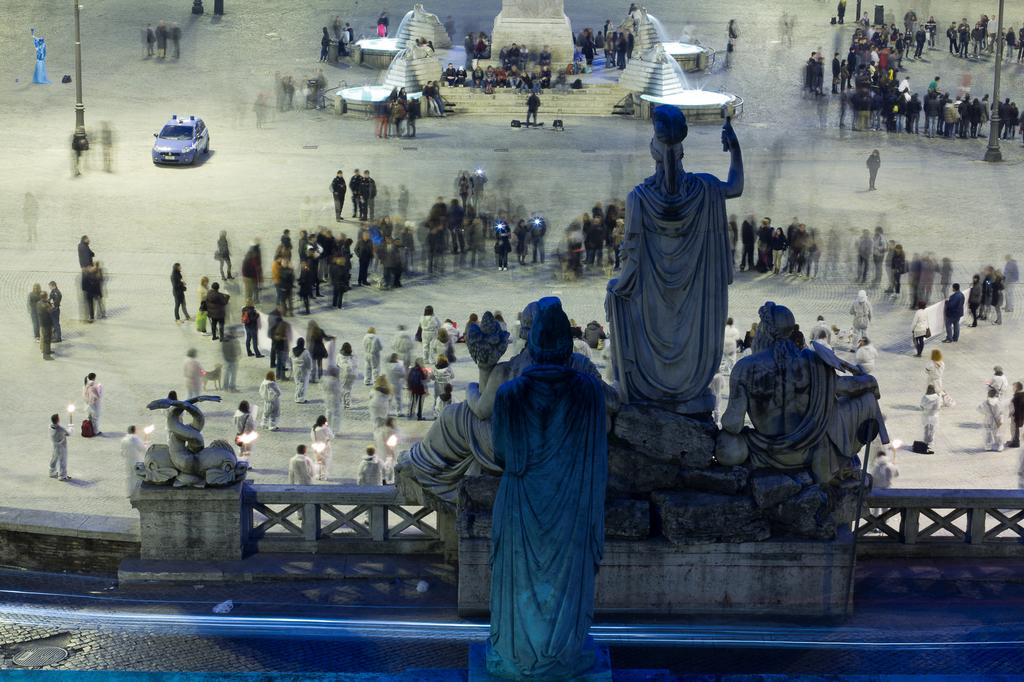What type of art can be seen in the image? There are sculptures in the image. Can you describe the setting where the sculptures are located? There are people on the land in the image. What else is present in the image besides the sculptures and people? There is a vehicle visible in the image. What type of peace symbol can be seen in the image? There is no peace symbol present in the image; it features sculptures, people, and a vehicle. Is there a frame around the sculptures in the image? The provided facts do not mention a frame around the sculptures, so it cannot be determined from the image. 